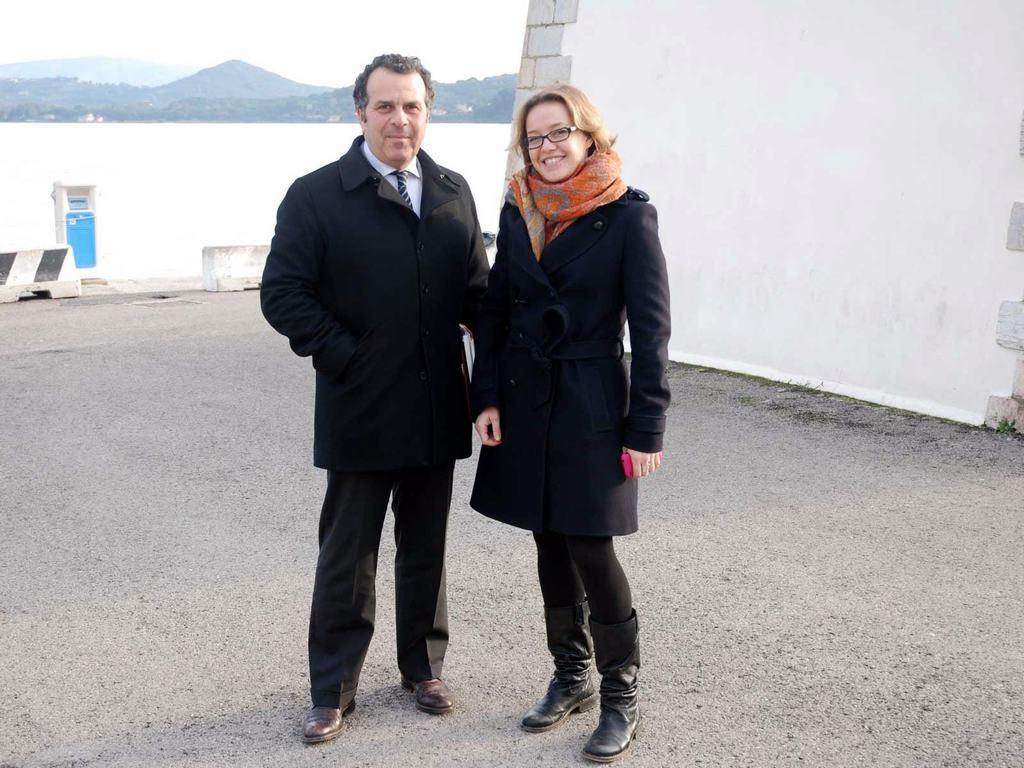Can you describe this image briefly? In this image, we can see two people standing. We can see the ground. We can see the wall and some dividers. There is a dustbin. We can see some water, a few hills and some grass. We can also see the sky. 